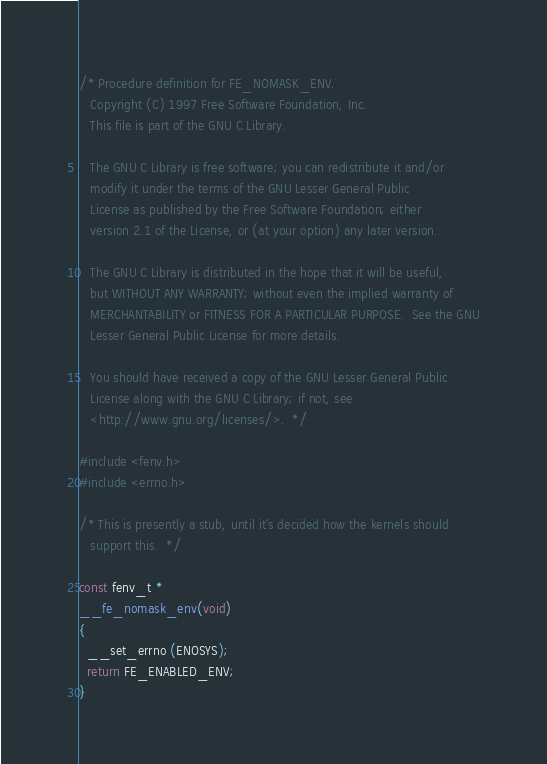<code> <loc_0><loc_0><loc_500><loc_500><_C_>/* Procedure definition for FE_NOMASK_ENV.
   Copyright (C) 1997 Free Software Foundation, Inc.
   This file is part of the GNU C Library.

   The GNU C Library is free software; you can redistribute it and/or
   modify it under the terms of the GNU Lesser General Public
   License as published by the Free Software Foundation; either
   version 2.1 of the License, or (at your option) any later version.

   The GNU C Library is distributed in the hope that it will be useful,
   but WITHOUT ANY WARRANTY; without even the implied warranty of
   MERCHANTABILITY or FITNESS FOR A PARTICULAR PURPOSE.  See the GNU
   Lesser General Public License for more details.

   You should have received a copy of the GNU Lesser General Public
   License along with the GNU C Library; if not, see
   <http://www.gnu.org/licenses/>.  */

#include <fenv.h>
#include <errno.h>

/* This is presently a stub, until it's decided how the kernels should
   support this.  */

const fenv_t *
__fe_nomask_env(void)
{
  __set_errno (ENOSYS);
  return FE_ENABLED_ENV;
}

</code> 